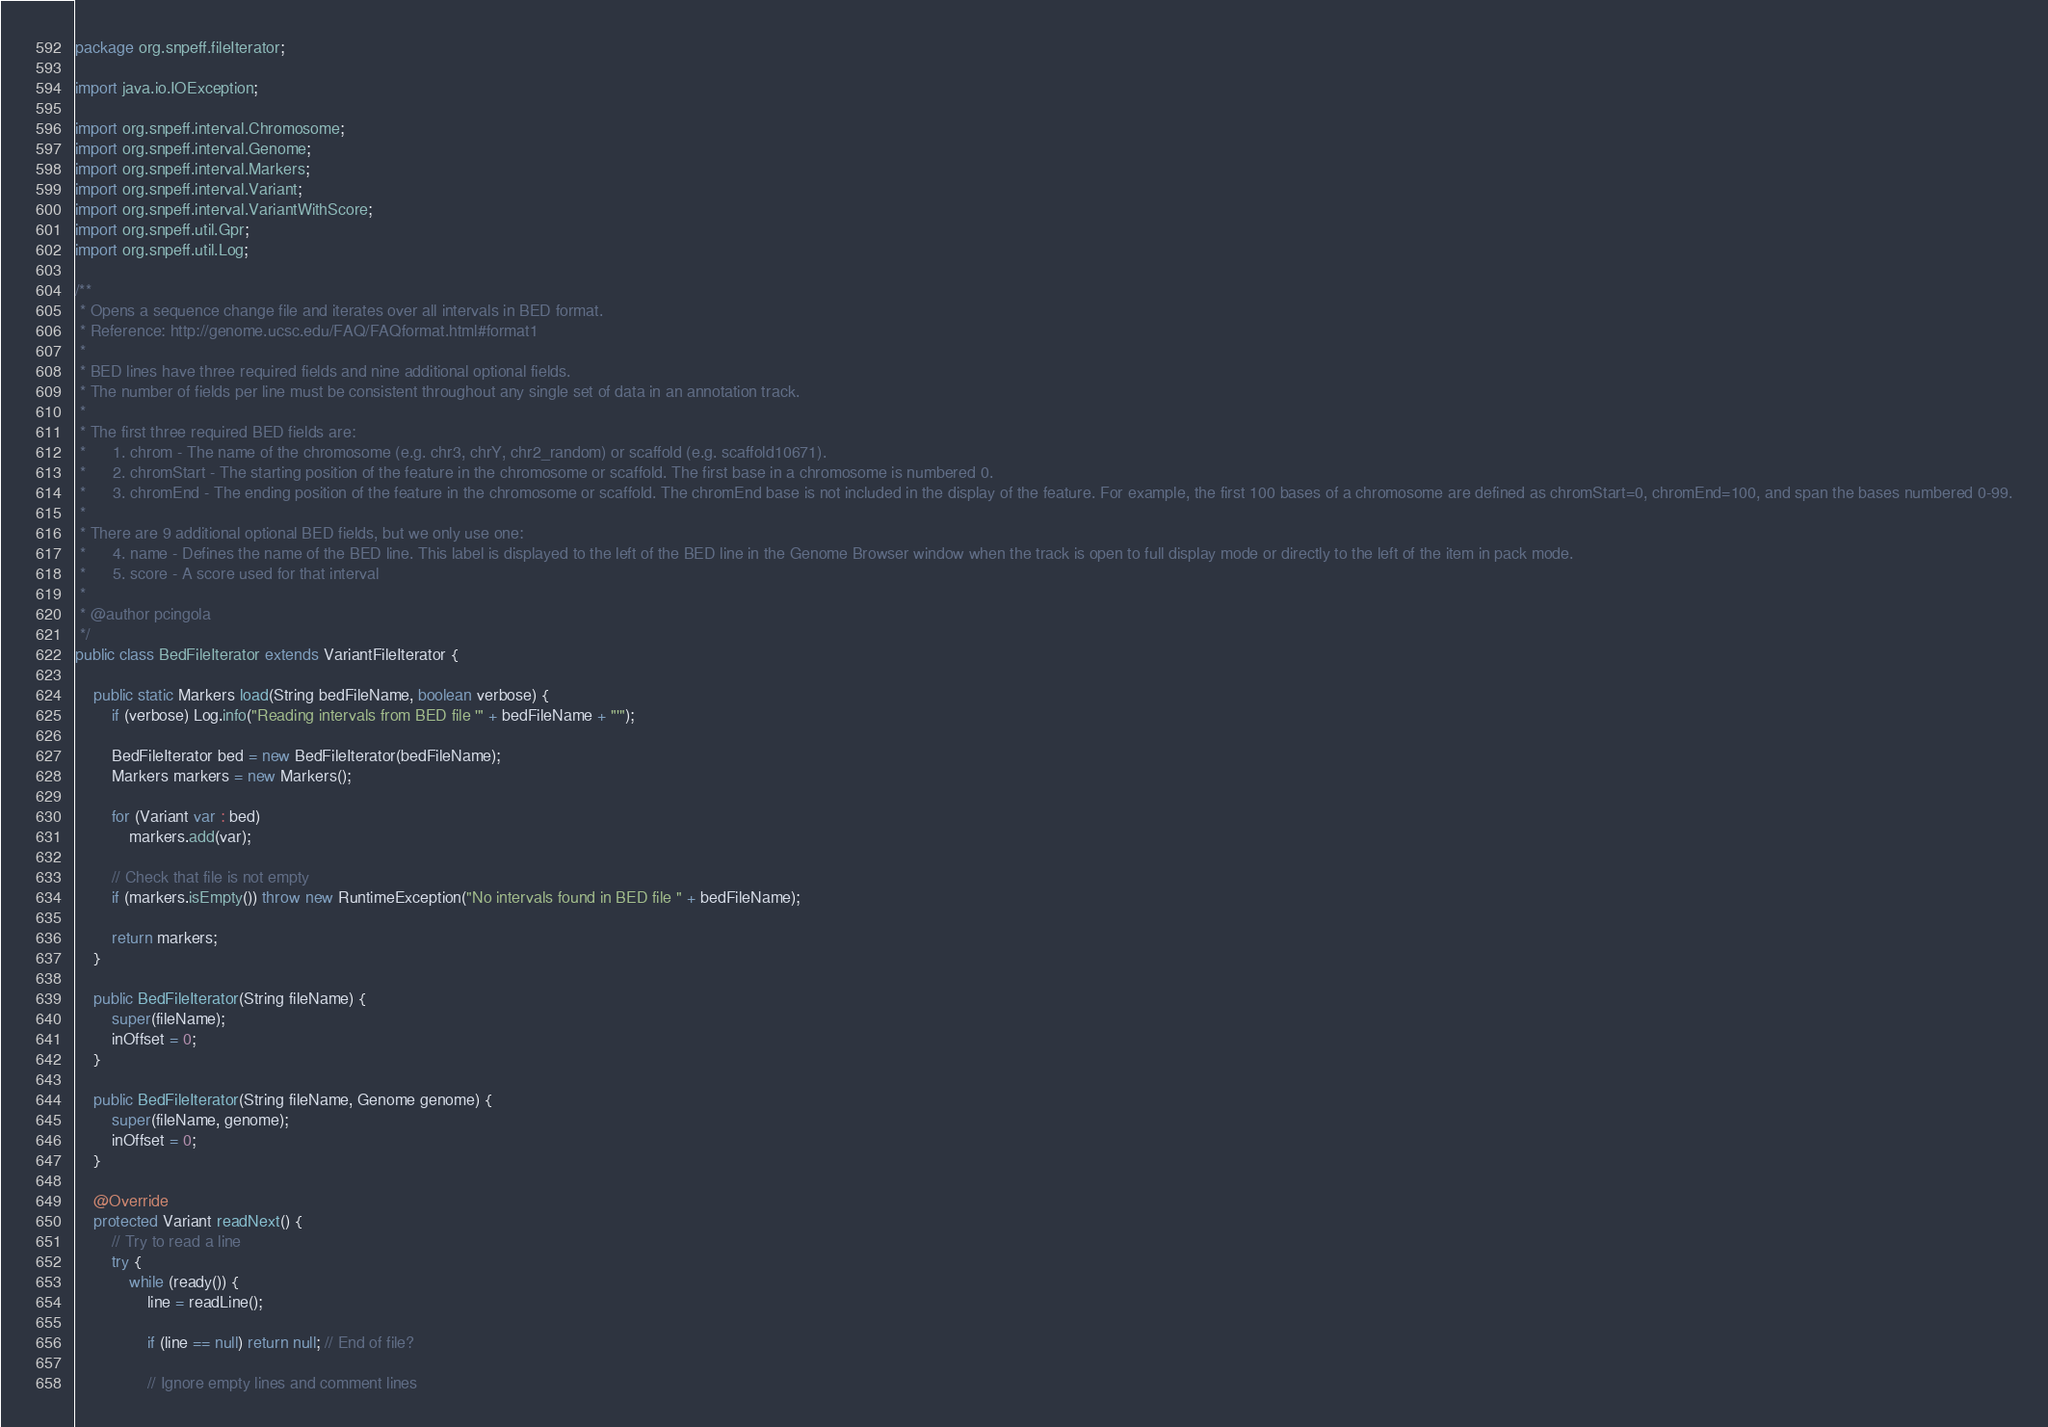Convert code to text. <code><loc_0><loc_0><loc_500><loc_500><_Java_>package org.snpeff.fileIterator;

import java.io.IOException;

import org.snpeff.interval.Chromosome;
import org.snpeff.interval.Genome;
import org.snpeff.interval.Markers;
import org.snpeff.interval.Variant;
import org.snpeff.interval.VariantWithScore;
import org.snpeff.util.Gpr;
import org.snpeff.util.Log;

/**
 * Opens a sequence change file and iterates over all intervals in BED format.
 * Reference: http://genome.ucsc.edu/FAQ/FAQformat.html#format1
 *
 * BED lines have three required fields and nine additional optional fields.
 * The number of fields per line must be consistent throughout any single set of data in an annotation track.
 *
 * The first three required BED fields are:
 * 		1. chrom - The name of the chromosome (e.g. chr3, chrY, chr2_random) or scaffold (e.g. scaffold10671).
 * 		2. chromStart - The starting position of the feature in the chromosome or scaffold. The first base in a chromosome is numbered 0.
 * 		3. chromEnd - The ending position of the feature in the chromosome or scaffold. The chromEnd base is not included in the display of the feature. For example, the first 100 bases of a chromosome are defined as chromStart=0, chromEnd=100, and span the bases numbered 0-99.
 *
 * There are 9 additional optional BED fields, but we only use one:
 * 		4. name - Defines the name of the BED line. This label is displayed to the left of the BED line in the Genome Browser window when the track is open to full display mode or directly to the left of the item in pack mode.
 * 		5. score - A score used for that interval
 *
 * @author pcingola
 */
public class BedFileIterator extends VariantFileIterator {

	public static Markers load(String bedFileName, boolean verbose) {
		if (verbose) Log.info("Reading intervals from BED file '" + bedFileName + "'");

		BedFileIterator bed = new BedFileIterator(bedFileName);
		Markers markers = new Markers();

		for (Variant var : bed)
			markers.add(var);

		// Check that file is not empty
		if (markers.isEmpty()) throw new RuntimeException("No intervals found in BED file " + bedFileName);

		return markers;
	}

	public BedFileIterator(String fileName) {
		super(fileName);
		inOffset = 0;
	}

	public BedFileIterator(String fileName, Genome genome) {
		super(fileName, genome);
		inOffset = 0;
	}

	@Override
	protected Variant readNext() {
		// Try to read a line
		try {
			while (ready()) {
				line = readLine();

				if (line == null) return null; // End of file?

				// Ignore empty lines and comment lines</code> 